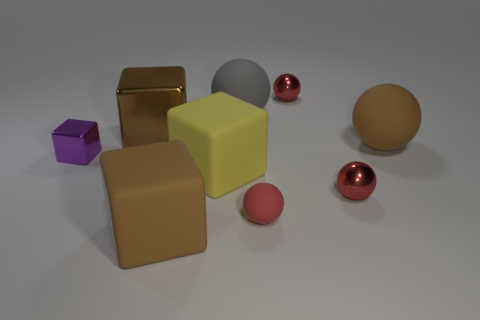There is a small red ball behind the large metal block; how many large gray rubber things are behind it?
Provide a short and direct response. 0. What number of other objects are there of the same material as the gray thing?
Ensure brevity in your answer.  4. Do the large brown thing that is in front of the tiny red matte object and the big brown thing that is on the right side of the tiny red rubber thing have the same material?
Ensure brevity in your answer.  Yes. Is there any other thing that has the same shape as the small rubber thing?
Make the answer very short. Yes. Does the brown sphere have the same material as the brown object in front of the small purple block?
Make the answer very short. Yes. There is a matte ball right of the tiny red metallic sphere that is in front of the large yellow object on the left side of the tiny red matte thing; what is its color?
Ensure brevity in your answer.  Brown. The gray object that is the same size as the brown metallic thing is what shape?
Ensure brevity in your answer.  Sphere. Are there any other things that are the same size as the yellow matte block?
Make the answer very short. Yes. There is a shiny thing that is in front of the small purple thing; is its size the same as the rubber thing behind the brown rubber sphere?
Your response must be concise. No. What size is the brown cube that is in front of the small rubber object?
Provide a short and direct response. Large. 